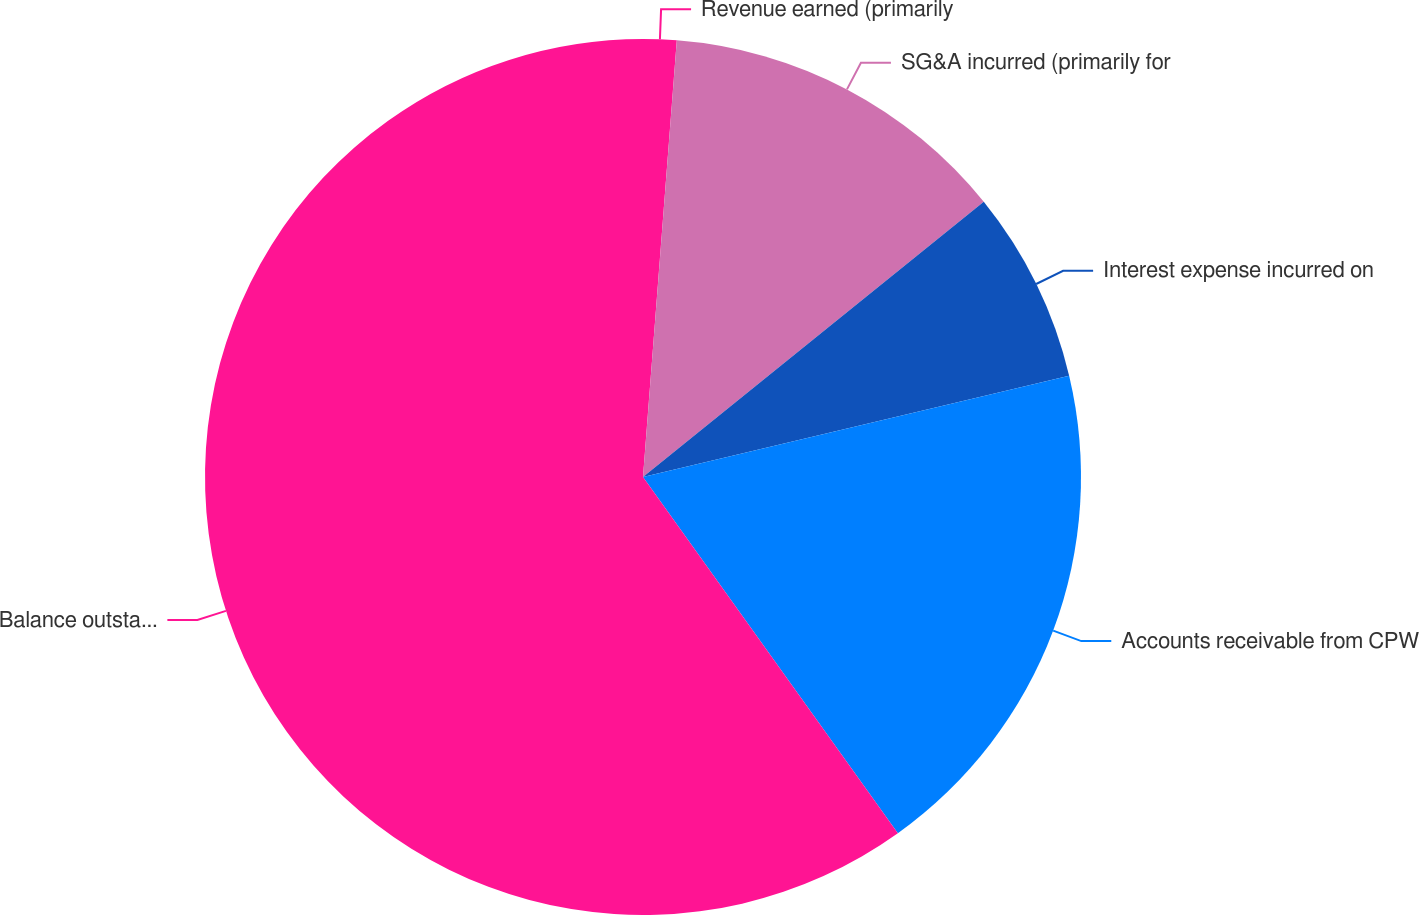<chart> <loc_0><loc_0><loc_500><loc_500><pie_chart><fcel>Revenue earned (primarily<fcel>SG&A incurred (primarily for<fcel>Interest expense incurred on<fcel>Accounts receivable from CPW<fcel>Balance outstanding on credit<nl><fcel>1.23%<fcel>12.96%<fcel>7.1%<fcel>18.83%<fcel>59.89%<nl></chart> 